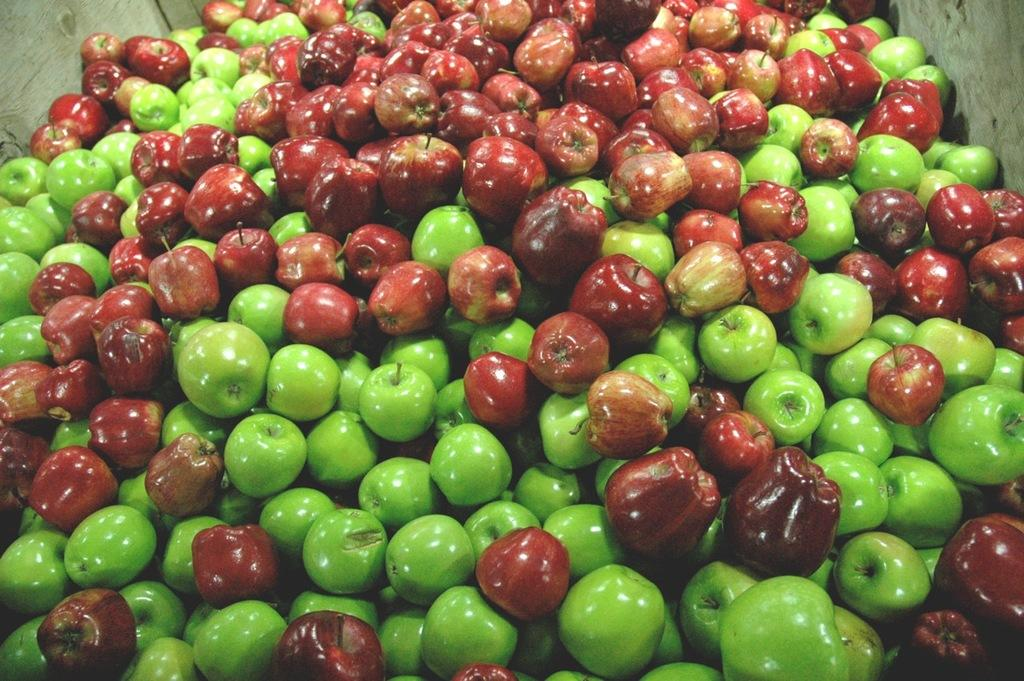What type of fruit is present in the image? There are red apples and green apples in the image. Can you describe the color of the apples? The red apples are red, and the green apples are green. How many passengers are sitting on the apples in the image? There are no passengers present in the image, as it features apples. 